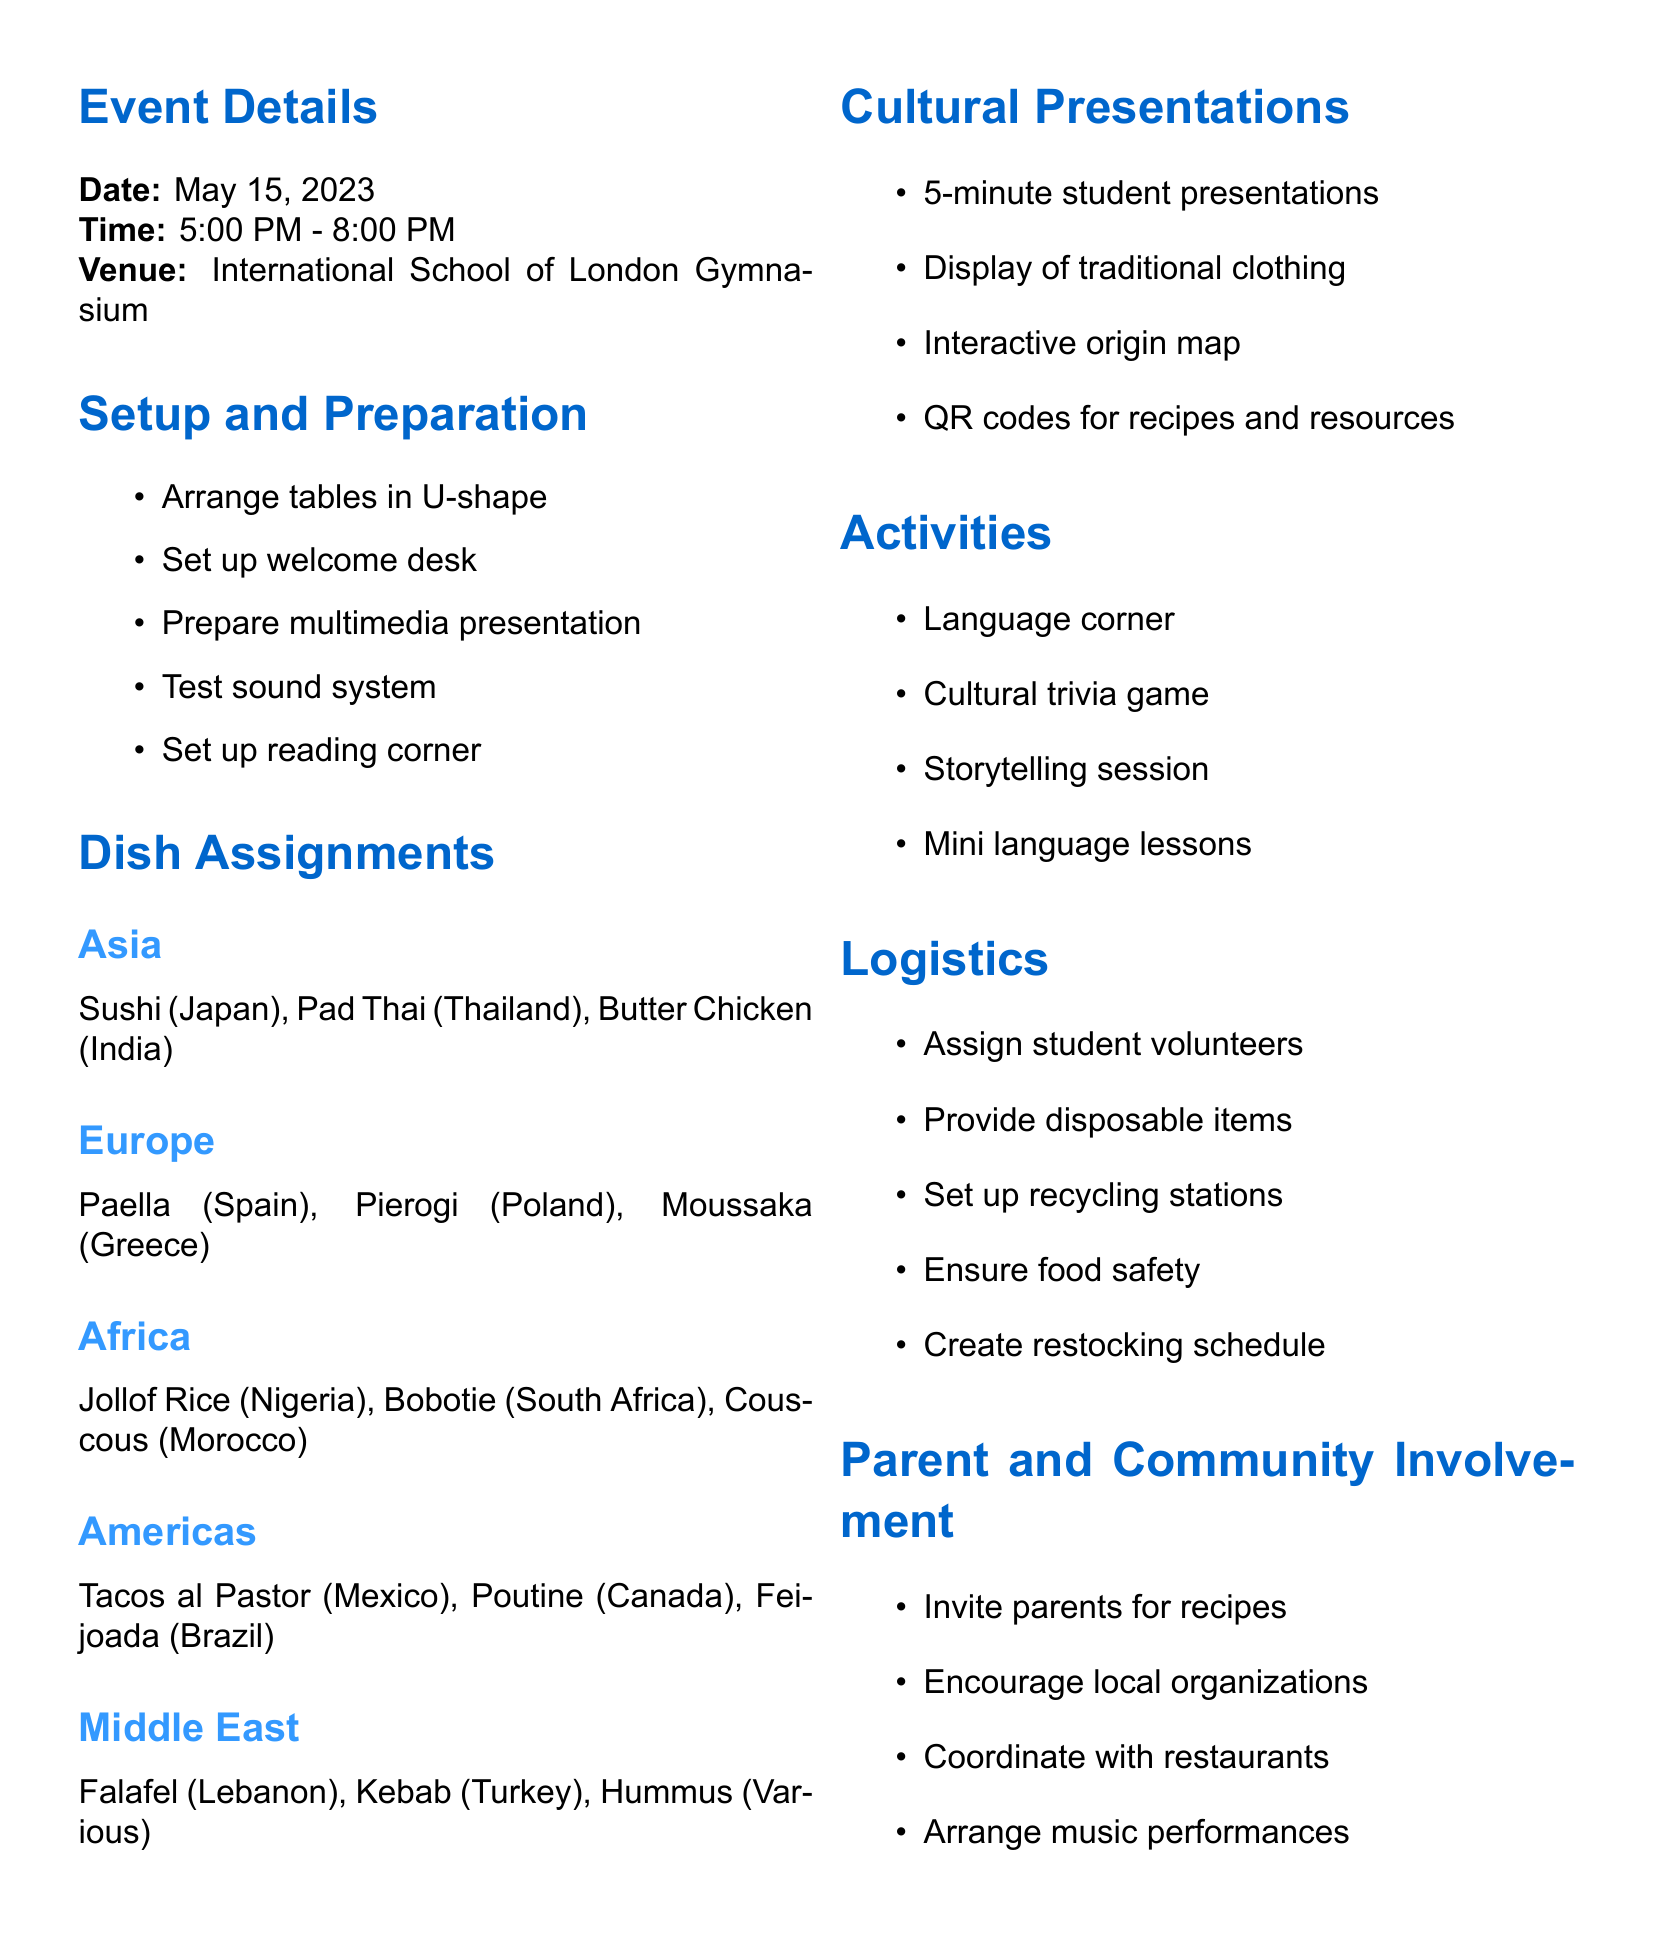What is the name of the event? The title of the event mentioned in the document is "Global Flavors: Celebrating Our Cultural Heritage."
Answer: Global Flavors: Celebrating Our Cultural Heritage When is the food festival taking place? The date listed for the event is May 15, 2023.
Answer: May 15, 2023 What time does the event start? The starting time of the event is provided in the document.
Answer: 5:00 PM What is the venue for the festival? The document specifies the location of the event as the International School of London Gymnasium.
Answer: International School of London Gymnasium Which dish is assigned to Asia? The document includes several dishes, and one is specified for Asia.
Answer: Sushi (Japan) What types of activities are scheduled? The document outlines activities associated with the festival, one of which is a trivia game.
Answer: Cultural trivia game How long are the student presentations? The document indicates the duration of the student presentations related to cultural dishes.
Answer: 5 minutes Who is invited to contribute recipes? The document encourages a specific group to contribute recipes to the festival.
Answer: Parents What is one logistics item mentioned? The document contains a section on logistics, where one item discusses food safety.
Answer: Ensure food safety 